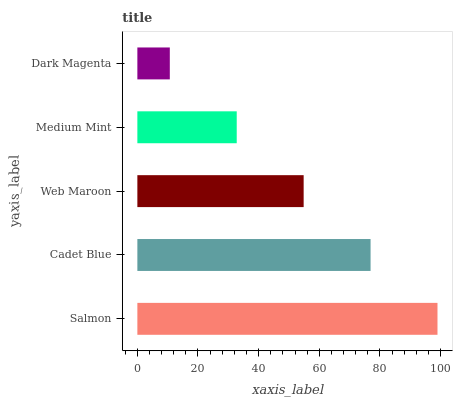Is Dark Magenta the minimum?
Answer yes or no. Yes. Is Salmon the maximum?
Answer yes or no. Yes. Is Cadet Blue the minimum?
Answer yes or no. No. Is Cadet Blue the maximum?
Answer yes or no. No. Is Salmon greater than Cadet Blue?
Answer yes or no. Yes. Is Cadet Blue less than Salmon?
Answer yes or no. Yes. Is Cadet Blue greater than Salmon?
Answer yes or no. No. Is Salmon less than Cadet Blue?
Answer yes or no. No. Is Web Maroon the high median?
Answer yes or no. Yes. Is Web Maroon the low median?
Answer yes or no. Yes. Is Dark Magenta the high median?
Answer yes or no. No. Is Salmon the low median?
Answer yes or no. No. 